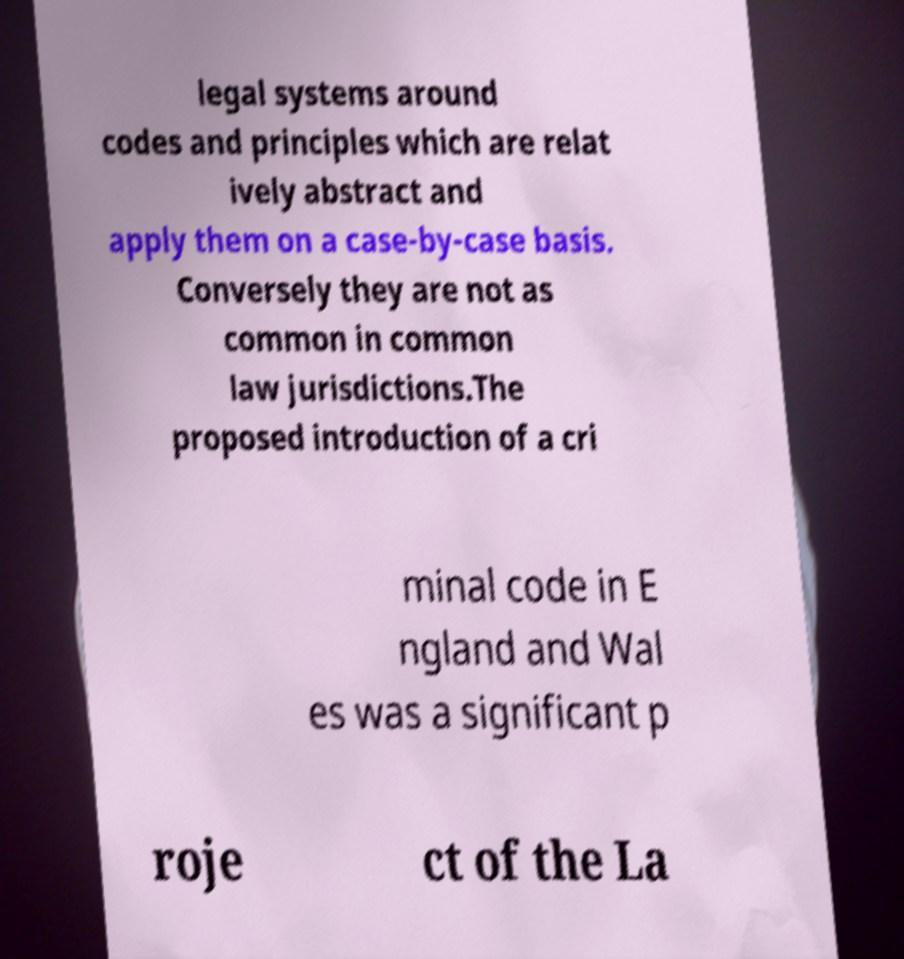I need the written content from this picture converted into text. Can you do that? legal systems around codes and principles which are relat ively abstract and apply them on a case-by-case basis. Conversely they are not as common in common law jurisdictions.The proposed introduction of a cri minal code in E ngland and Wal es was a significant p roje ct of the La 